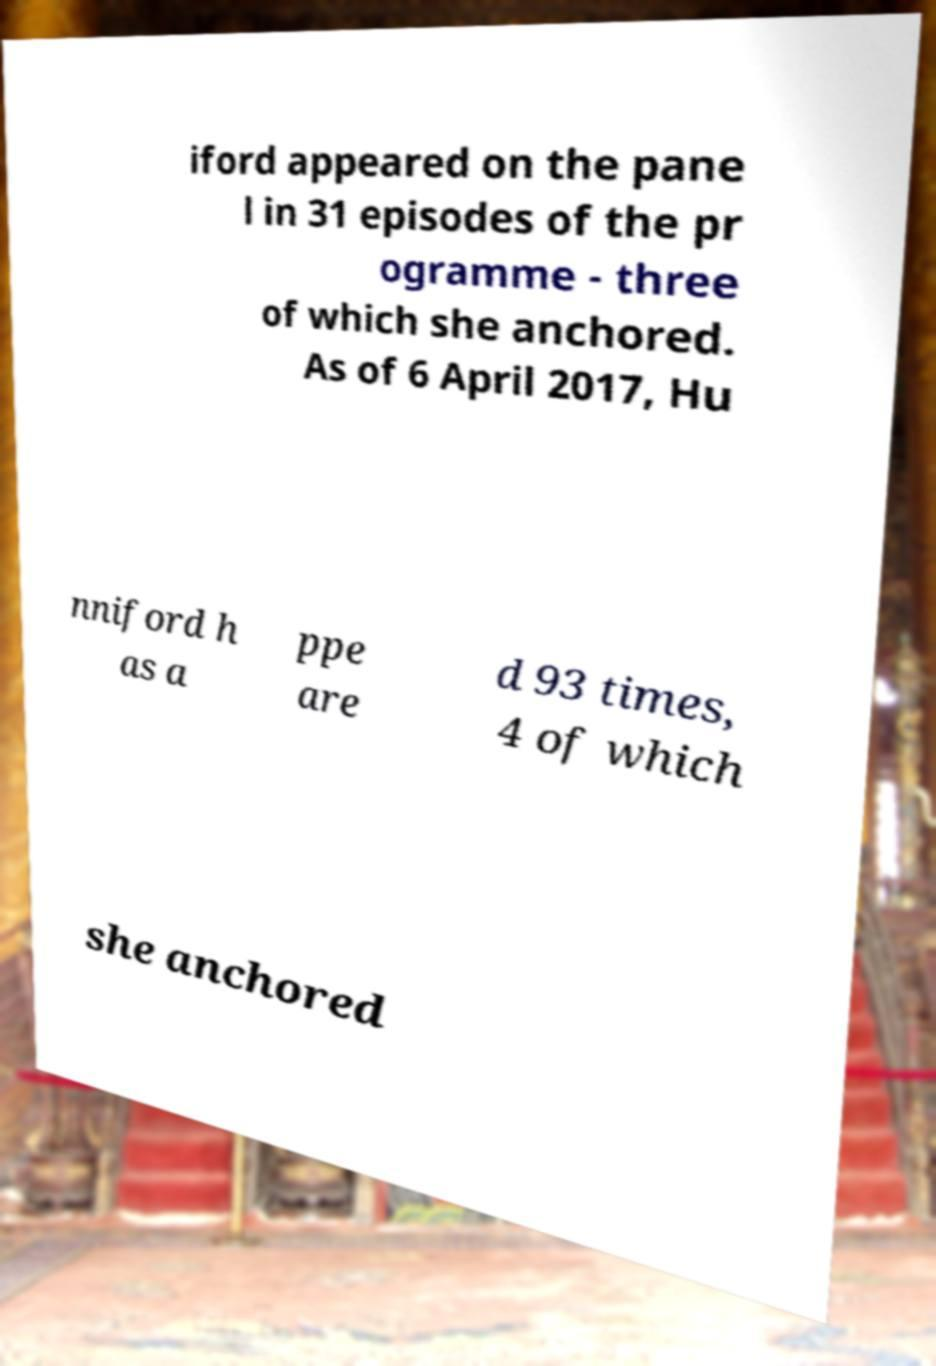Could you assist in decoding the text presented in this image and type it out clearly? iford appeared on the pane l in 31 episodes of the pr ogramme - three of which she anchored. As of 6 April 2017, Hu nniford h as a ppe are d 93 times, 4 of which she anchored 